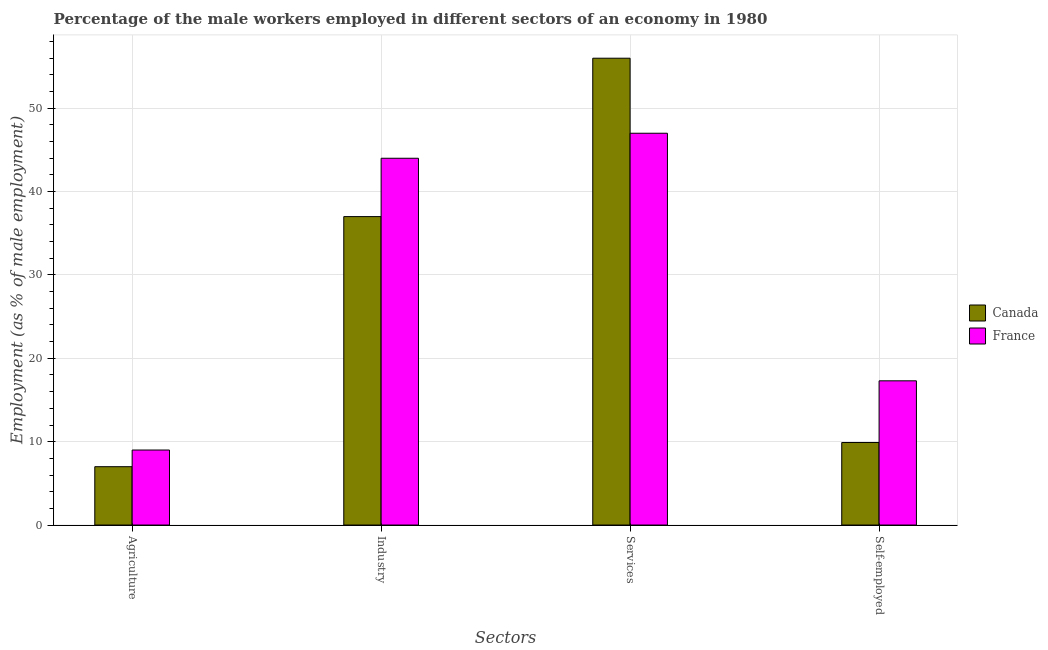How many groups of bars are there?
Provide a short and direct response. 4. Are the number of bars per tick equal to the number of legend labels?
Keep it short and to the point. Yes. Are the number of bars on each tick of the X-axis equal?
Provide a succinct answer. Yes. How many bars are there on the 1st tick from the left?
Offer a terse response. 2. How many bars are there on the 3rd tick from the right?
Provide a short and direct response. 2. What is the label of the 2nd group of bars from the left?
Provide a succinct answer. Industry. Across all countries, what is the maximum percentage of male workers in industry?
Offer a terse response. 44. In which country was the percentage of self employed male workers maximum?
Make the answer very short. France. In which country was the percentage of male workers in services minimum?
Offer a terse response. France. What is the total percentage of male workers in services in the graph?
Your response must be concise. 103. What is the difference between the percentage of male workers in agriculture in Canada and the percentage of male workers in services in France?
Your answer should be very brief. -40. What is the average percentage of male workers in services per country?
Offer a very short reply. 51.5. What is the difference between the percentage of self employed male workers and percentage of male workers in industry in Canada?
Ensure brevity in your answer.  -27.1. In how many countries, is the percentage of male workers in industry greater than 50 %?
Ensure brevity in your answer.  0. What is the ratio of the percentage of self employed male workers in Canada to that in France?
Ensure brevity in your answer.  0.57. In how many countries, is the percentage of self employed male workers greater than the average percentage of self employed male workers taken over all countries?
Give a very brief answer. 1. Is the sum of the percentage of male workers in industry in Canada and France greater than the maximum percentage of self employed male workers across all countries?
Your answer should be compact. Yes. What does the 1st bar from the right in Self-employed represents?
Provide a short and direct response. France. Is it the case that in every country, the sum of the percentage of male workers in agriculture and percentage of male workers in industry is greater than the percentage of male workers in services?
Your answer should be very brief. No. Are all the bars in the graph horizontal?
Your answer should be very brief. No. How many countries are there in the graph?
Keep it short and to the point. 2. What is the difference between two consecutive major ticks on the Y-axis?
Your response must be concise. 10. Are the values on the major ticks of Y-axis written in scientific E-notation?
Make the answer very short. No. Does the graph contain any zero values?
Your answer should be very brief. No. How many legend labels are there?
Keep it short and to the point. 2. How are the legend labels stacked?
Offer a very short reply. Vertical. What is the title of the graph?
Your response must be concise. Percentage of the male workers employed in different sectors of an economy in 1980. What is the label or title of the X-axis?
Your answer should be compact. Sectors. What is the label or title of the Y-axis?
Ensure brevity in your answer.  Employment (as % of male employment). What is the Employment (as % of male employment) in Canada in Agriculture?
Offer a very short reply. 7. What is the Employment (as % of male employment) of France in Industry?
Ensure brevity in your answer.  44. What is the Employment (as % of male employment) in Canada in Services?
Keep it short and to the point. 56. What is the Employment (as % of male employment) of France in Services?
Offer a terse response. 47. What is the Employment (as % of male employment) in Canada in Self-employed?
Offer a terse response. 9.9. What is the Employment (as % of male employment) in France in Self-employed?
Provide a succinct answer. 17.3. What is the total Employment (as % of male employment) in Canada in the graph?
Your response must be concise. 109.9. What is the total Employment (as % of male employment) in France in the graph?
Provide a succinct answer. 117.3. What is the difference between the Employment (as % of male employment) of France in Agriculture and that in Industry?
Ensure brevity in your answer.  -35. What is the difference between the Employment (as % of male employment) in Canada in Agriculture and that in Services?
Your answer should be compact. -49. What is the difference between the Employment (as % of male employment) in France in Agriculture and that in Services?
Provide a short and direct response. -38. What is the difference between the Employment (as % of male employment) of Canada in Agriculture and that in Self-employed?
Make the answer very short. -2.9. What is the difference between the Employment (as % of male employment) in France in Agriculture and that in Self-employed?
Keep it short and to the point. -8.3. What is the difference between the Employment (as % of male employment) in Canada in Industry and that in Self-employed?
Give a very brief answer. 27.1. What is the difference between the Employment (as % of male employment) in France in Industry and that in Self-employed?
Provide a succinct answer. 26.7. What is the difference between the Employment (as % of male employment) of Canada in Services and that in Self-employed?
Make the answer very short. 46.1. What is the difference between the Employment (as % of male employment) in France in Services and that in Self-employed?
Your answer should be compact. 29.7. What is the difference between the Employment (as % of male employment) of Canada in Agriculture and the Employment (as % of male employment) of France in Industry?
Offer a very short reply. -37. What is the difference between the Employment (as % of male employment) of Canada in Services and the Employment (as % of male employment) of France in Self-employed?
Make the answer very short. 38.7. What is the average Employment (as % of male employment) in Canada per Sectors?
Keep it short and to the point. 27.48. What is the average Employment (as % of male employment) in France per Sectors?
Give a very brief answer. 29.32. What is the difference between the Employment (as % of male employment) of Canada and Employment (as % of male employment) of France in Industry?
Offer a very short reply. -7. What is the difference between the Employment (as % of male employment) of Canada and Employment (as % of male employment) of France in Services?
Your response must be concise. 9. What is the difference between the Employment (as % of male employment) in Canada and Employment (as % of male employment) in France in Self-employed?
Make the answer very short. -7.4. What is the ratio of the Employment (as % of male employment) in Canada in Agriculture to that in Industry?
Ensure brevity in your answer.  0.19. What is the ratio of the Employment (as % of male employment) in France in Agriculture to that in Industry?
Provide a short and direct response. 0.2. What is the ratio of the Employment (as % of male employment) in Canada in Agriculture to that in Services?
Your response must be concise. 0.12. What is the ratio of the Employment (as % of male employment) in France in Agriculture to that in Services?
Your response must be concise. 0.19. What is the ratio of the Employment (as % of male employment) in Canada in Agriculture to that in Self-employed?
Offer a very short reply. 0.71. What is the ratio of the Employment (as % of male employment) in France in Agriculture to that in Self-employed?
Your answer should be compact. 0.52. What is the ratio of the Employment (as % of male employment) in Canada in Industry to that in Services?
Ensure brevity in your answer.  0.66. What is the ratio of the Employment (as % of male employment) in France in Industry to that in Services?
Make the answer very short. 0.94. What is the ratio of the Employment (as % of male employment) in Canada in Industry to that in Self-employed?
Keep it short and to the point. 3.74. What is the ratio of the Employment (as % of male employment) of France in Industry to that in Self-employed?
Provide a succinct answer. 2.54. What is the ratio of the Employment (as % of male employment) of Canada in Services to that in Self-employed?
Offer a very short reply. 5.66. What is the ratio of the Employment (as % of male employment) of France in Services to that in Self-employed?
Provide a short and direct response. 2.72. What is the difference between the highest and the second highest Employment (as % of male employment) of Canada?
Ensure brevity in your answer.  19. What is the difference between the highest and the second highest Employment (as % of male employment) of France?
Keep it short and to the point. 3. What is the difference between the highest and the lowest Employment (as % of male employment) of France?
Your answer should be compact. 38. 